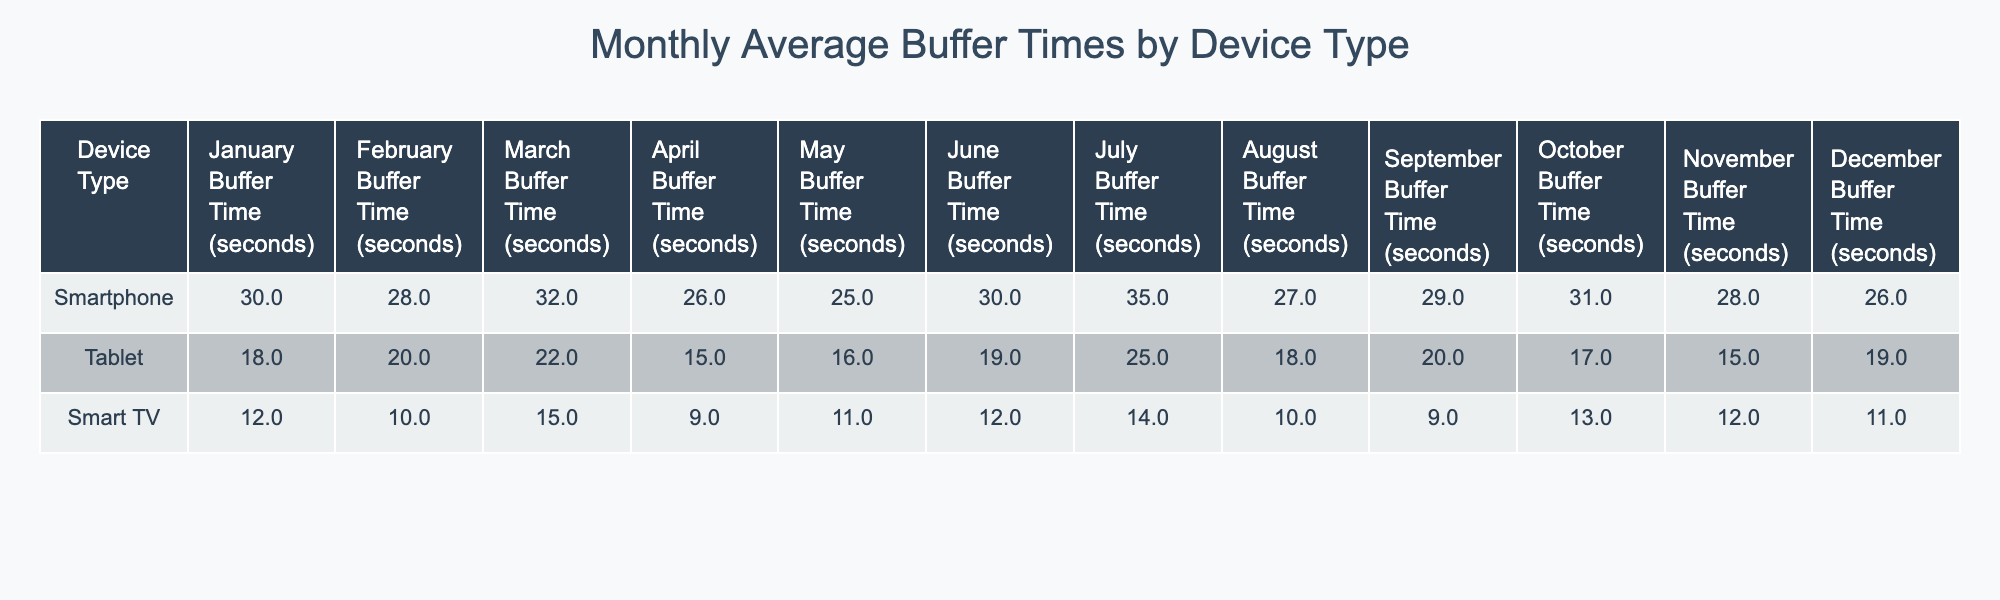What is the average buffer time for smartphones in June? The buffer time for smartphones in June is 30 seconds, as indicated directly in the table under the June column for the Smartphone row.
Answer: 30 seconds Which device type had the highest buffer time in March? The table shows that the Smartphone has a buffer time of 32 seconds in March, which is higher than the Tablet's 22 seconds and the Smart TV's 15 seconds.
Answer: Smartphone What is the difference in buffer time between tablets and smart TVs in April? The buffer time for Tablets in April is 15 seconds, and for Smart TVs, it is 9 seconds. The difference is calculated as 15 - 9 = 6 seconds.
Answer: 6 seconds Was there a month when the buffer time for smart TVs was lower than that of smartphones? Yes, the Smart TV's buffer time was lower than that of smartphones in every month listed in the table, indicating consistently better performance for Smart TVs.
Answer: Yes Which device type showed the most significant decrease in buffer time from January to February? The Smartphone's buffer time decreased from 30 seconds in January to 28 seconds in February, while the Tablet decreased from 18 to 20 seconds, and Smart TV decreased from 12 to 10 seconds. The Smartphone showed a decrease of 2 seconds.
Answer: Smartphone What was the average buffer time for tablets over the year? The monthly buffer times for tablets are: 18, 20, 22, 15, 16, 19, 25, 18, 20, 17, 15, 19. Summing these gives a total of 224 seconds. There are 12 months, so the average is 224/12 = 18.67 seconds.
Answer: 18.67 seconds In which month did the smartphone experience its least buffer time? The smartphone had its least buffer time of 25 seconds in May, as indicated in the table.
Answer: May Which device had the most consistent buffer times across the year? By observing the data, the Smart TV had buffer times ranging from 9 to 15 seconds, showing the least variation, while smartphones showed more fluctuation.
Answer: Smart TV What is the percentage increase in buffer time for smartphones from June to July? The buffer time increased from 30 seconds in June to 35 seconds in July. The increase is 35 - 30 = 5 seconds. The percentage increase is (5/30)*100 = 16.67%.
Answer: 16.67% Was the average buffer time for Smart TVs higher or lower than that for Tablets? The average buffer time for Smart TVs is (12+10+15+9+11+12+14+10+9+13+12+11)/12 = 11 seconds, while for Tablets it's (18+20+22+15+16+19+25+18+20+17+15+19)/12 = 18.67 seconds. Therefore, Smart TVs had lower average buffer time.
Answer: Lower 